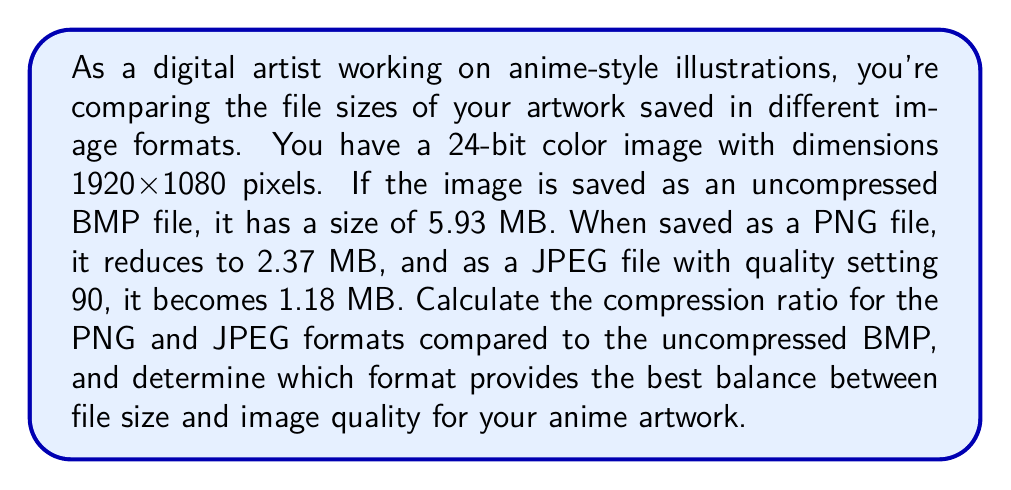What is the answer to this math problem? To solve this problem, we need to calculate the compression ratios for PNG and JPEG formats compared to the uncompressed BMP file. The compression ratio is defined as:

$$ \text{Compression Ratio} = \frac{\text{Uncompressed Size}}{\text{Compressed Size}} $$

First, let's convert all file sizes to bytes for consistency:
1. BMP: 5.93 MB = 5.93 × 1024 × 1024 = 6,217,728 bytes
2. PNG: 2.37 MB = 2.37 × 1024 × 1024 = 2,484,830 bytes
3. JPEG: 1.18 MB = 1.18 × 1024 × 1024 = 1,237,319 bytes

Now, let's calculate the compression ratios:

For PNG:
$$ \text{Compression Ratio}_{\text{PNG}} = \frac{6,217,728}{2,484,830} \approx 2.50 $$

For JPEG:
$$ \text{Compression Ratio}_{\text{JPEG}} = \frac{6,217,728}{1,237,319} \approx 5.02 $$

To determine which format provides the best balance between file size and image quality, we need to consider both the compression ratio and the nature of the compression:

1. PNG uses lossless compression, meaning it preserves all image data. It's ideal for images with sharp edges, text, and solid colors, which are common in anime-style artwork.

2. JPEG uses lossy compression, which can introduce artifacts, especially around sharp edges. However, it achieves a higher compression ratio.

For anime artwork, which often features solid colors, sharp lines, and text elements, PNG is generally the better choice despite its lower compression ratio. It preserves image quality without introducing artifacts that could be noticeable in the clean, stylized look of anime illustrations.
Answer: PNG Compression Ratio: 2.50
JPEG Compression Ratio: 5.02
Best format for anime artwork: PNG, as it provides lossless compression and preserves image quality, which is crucial for the sharp lines and solid colors typical in anime-style digital art. 